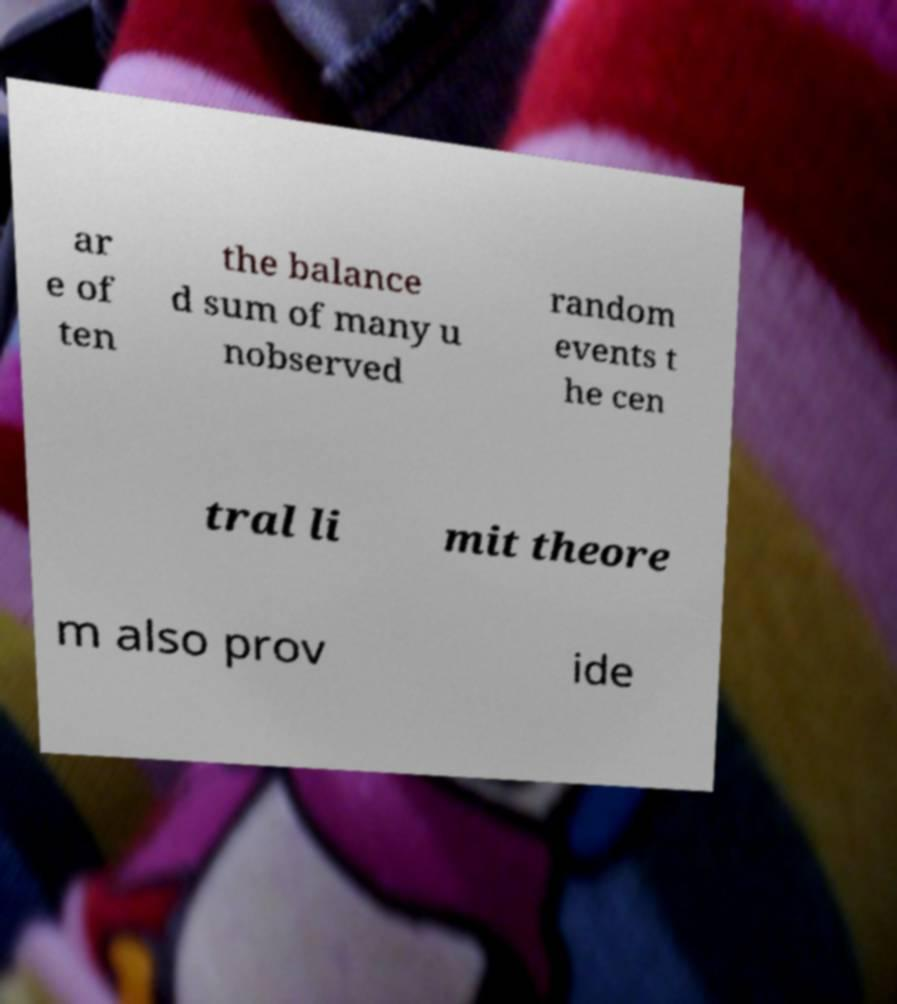What messages or text are displayed in this image? I need them in a readable, typed format. ar e of ten the balance d sum of many u nobserved random events t he cen tral li mit theore m also prov ide 